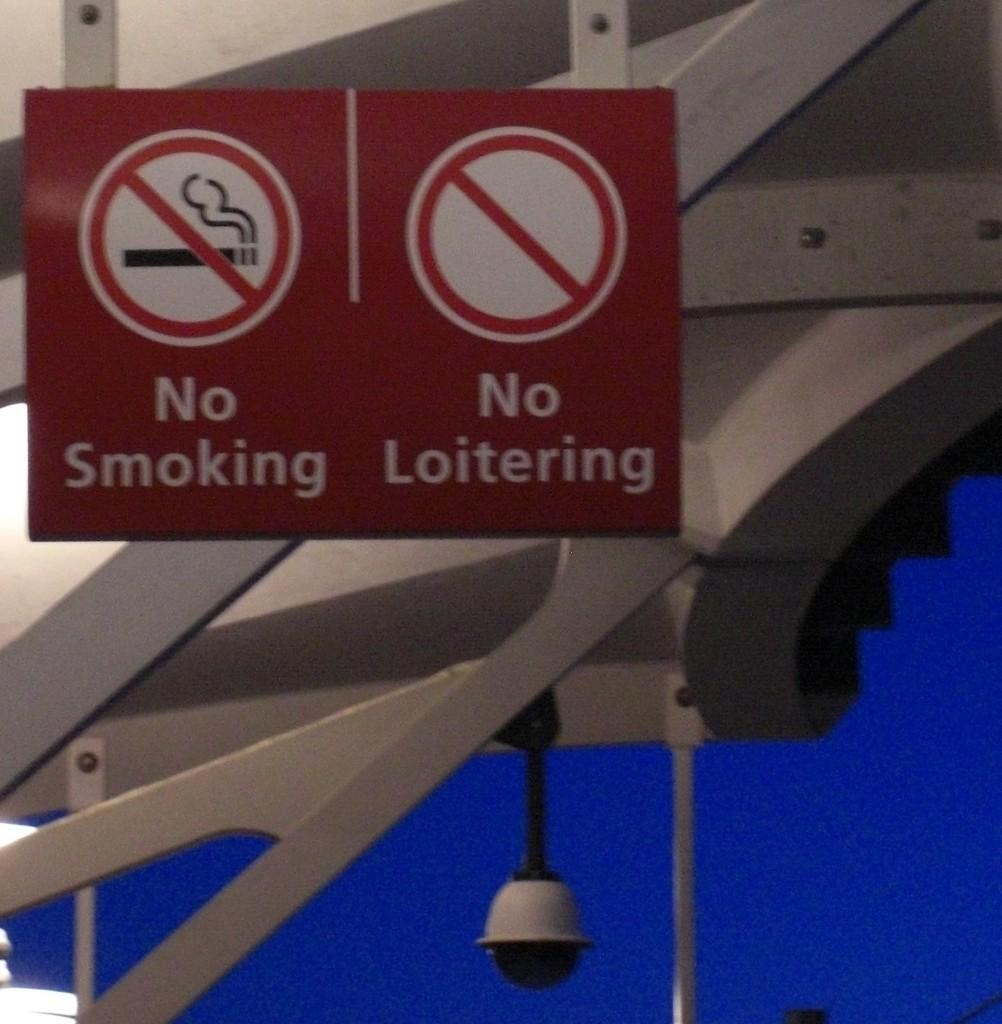<image>
Create a compact narrative representing the image presented. Two signs that read no smoking and no loitering. 